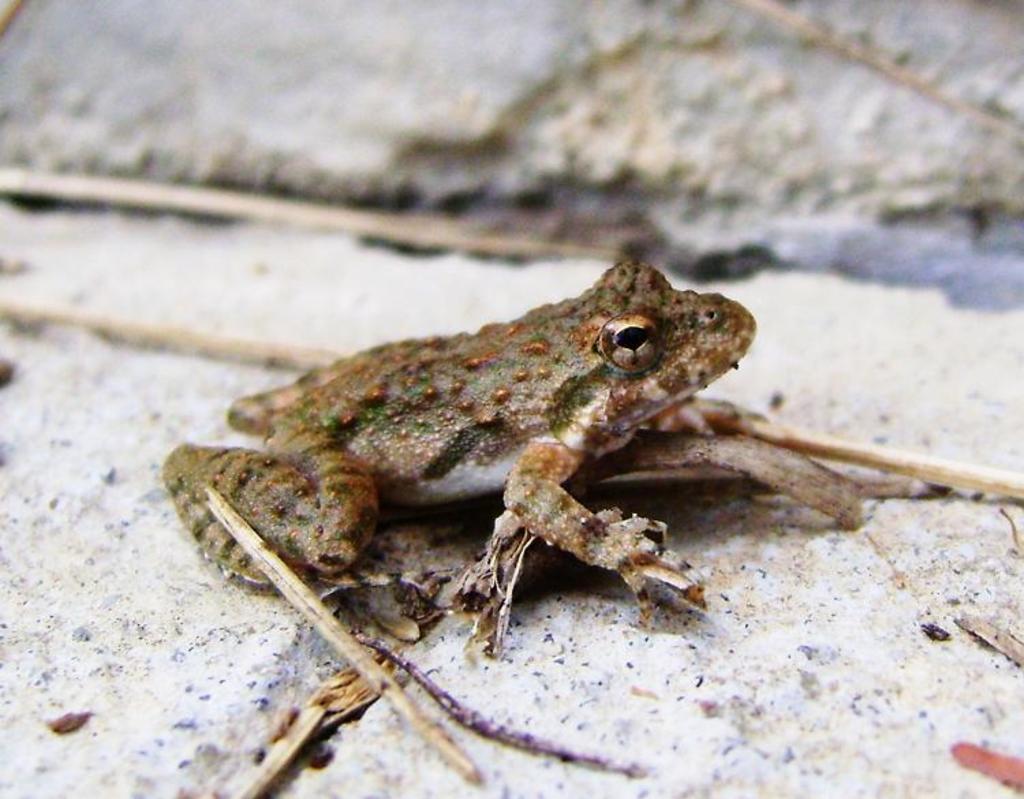Can you describe this image briefly? In the foreground of this image, there is a frog on the surface and we can also see few sticks. 